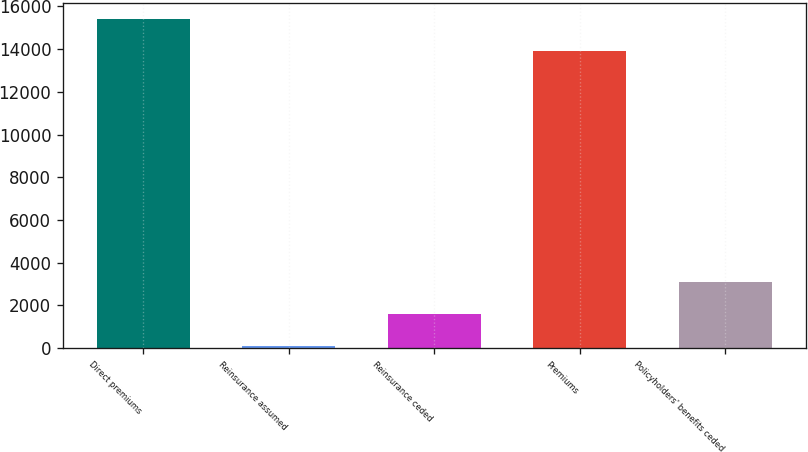Convert chart to OTSL. <chart><loc_0><loc_0><loc_500><loc_500><bar_chart><fcel>Direct premiums<fcel>Reinsurance assumed<fcel>Reinsurance ceded<fcel>Premiums<fcel>Policyholders' benefits ceded<nl><fcel>15410.3<fcel>99<fcel>1601.3<fcel>13908<fcel>3103.6<nl></chart> 